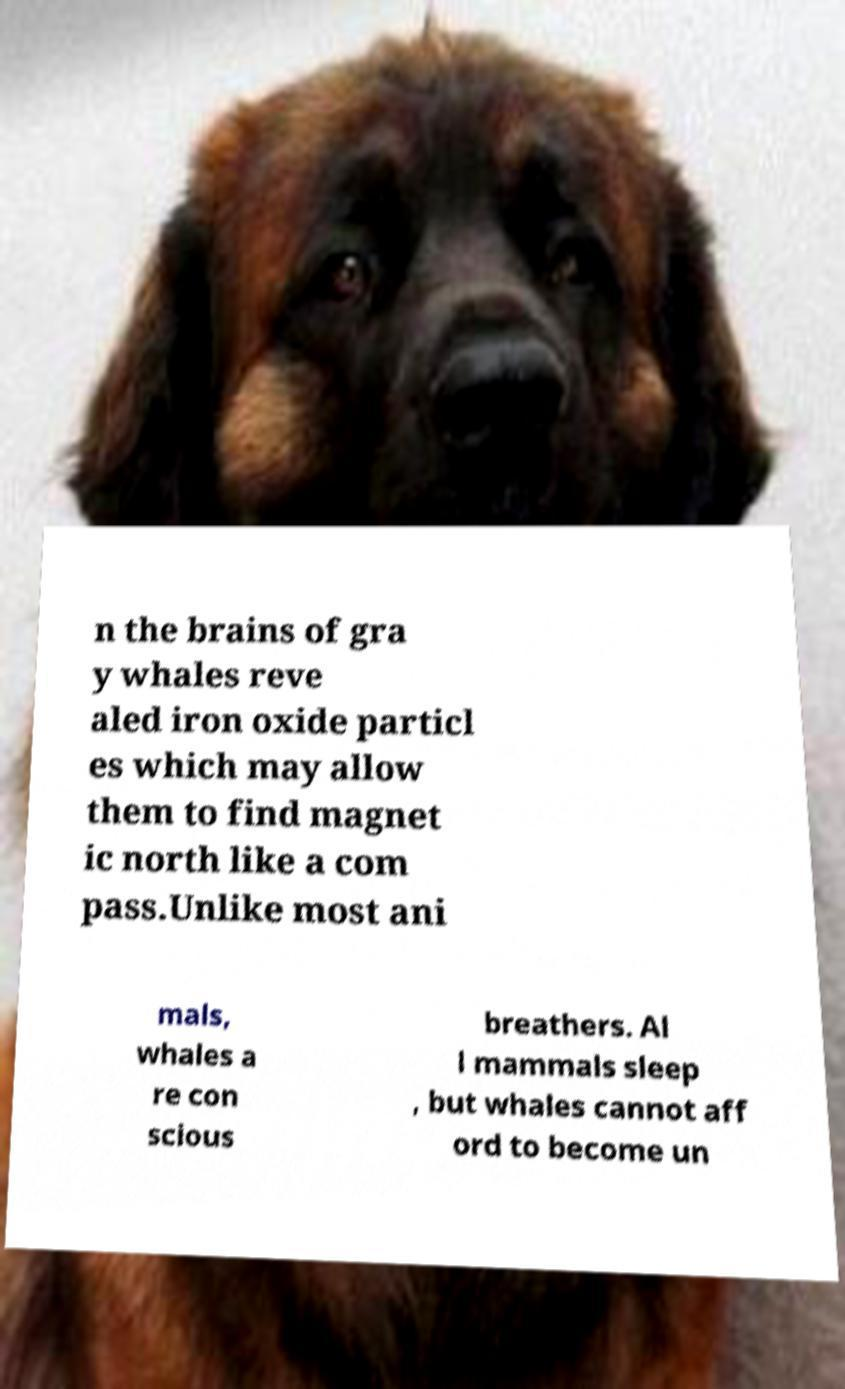Can you accurately transcribe the text from the provided image for me? n the brains of gra y whales reve aled iron oxide particl es which may allow them to find magnet ic north like a com pass.Unlike most ani mals, whales a re con scious breathers. Al l mammals sleep , but whales cannot aff ord to become un 